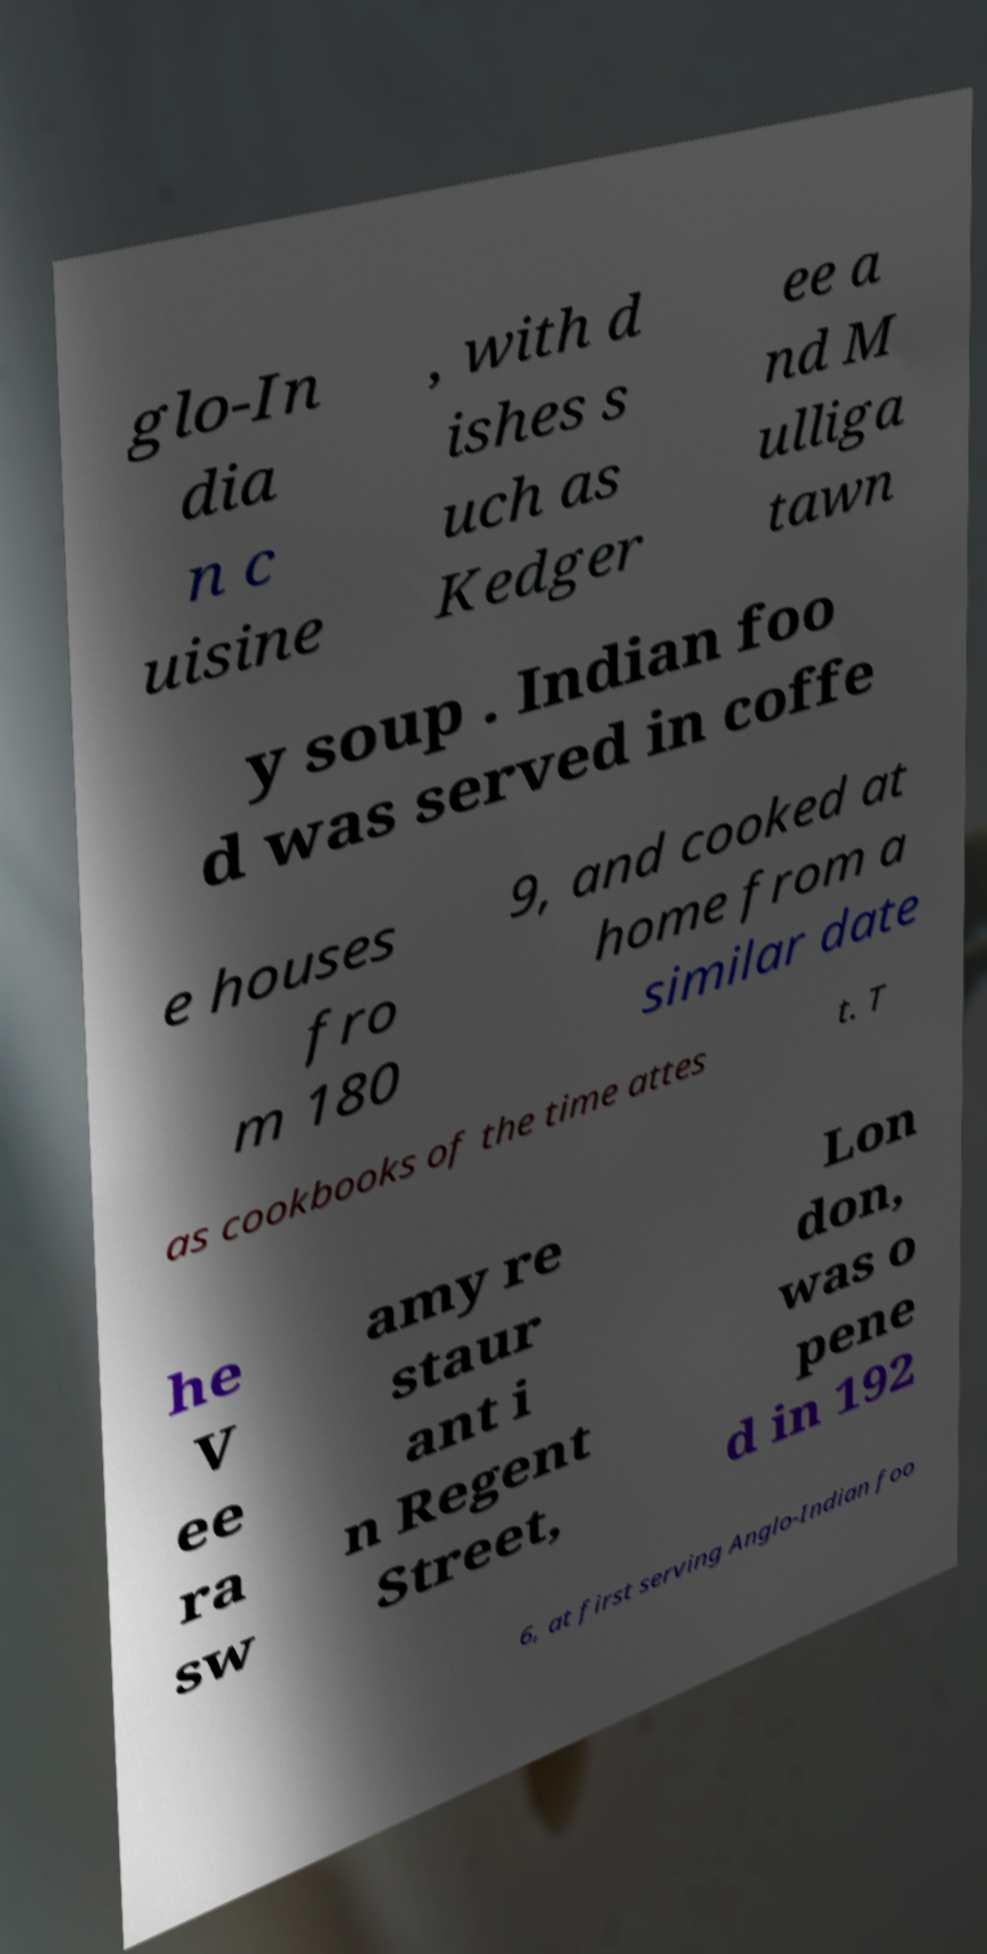There's text embedded in this image that I need extracted. Can you transcribe it verbatim? glo-In dia n c uisine , with d ishes s uch as Kedger ee a nd M ulliga tawn y soup . Indian foo d was served in coffe e houses fro m 180 9, and cooked at home from a similar date as cookbooks of the time attes t. T he V ee ra sw amy re staur ant i n Regent Street, Lon don, was o pene d in 192 6, at first serving Anglo-Indian foo 